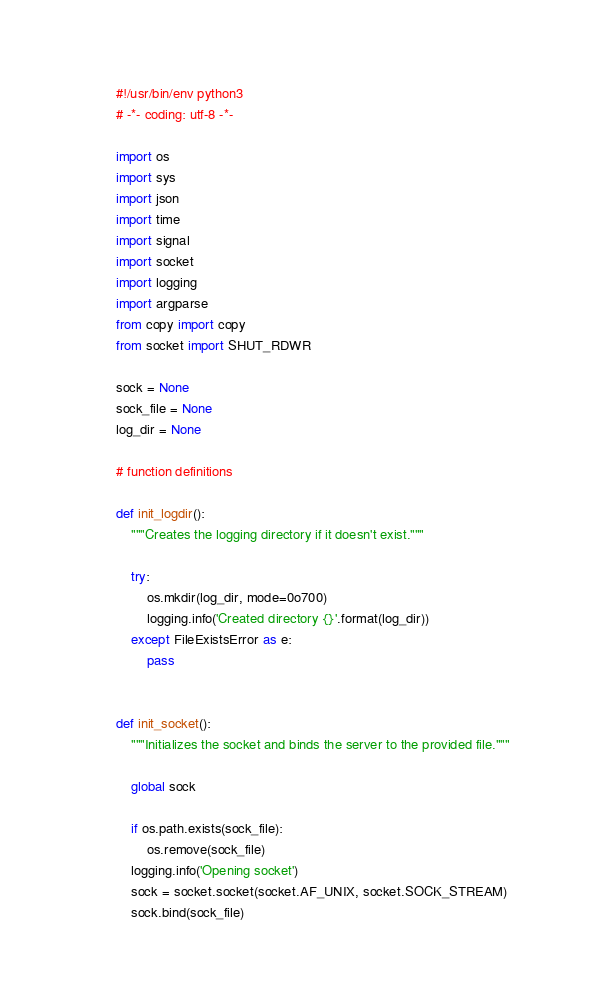<code> <loc_0><loc_0><loc_500><loc_500><_Python_>#!/usr/bin/env python3
# -*- coding: utf-8 -*-

import os
import sys
import json
import time
import signal
import socket
import logging
import argparse
from copy import copy
from socket import SHUT_RDWR

sock = None
sock_file = None
log_dir = None

# function definitions

def init_logdir():
    """Creates the logging directory if it doesn't exist."""

    try:
        os.mkdir(log_dir, mode=0o700)
        logging.info('Created directory {}'.format(log_dir))
    except FileExistsError as e:
        pass


def init_socket():
    """Initializes the socket and binds the server to the provided file."""

    global sock

    if os.path.exists(sock_file):
        os.remove(sock_file)
    logging.info('Opening socket')
    sock = socket.socket(socket.AF_UNIX, socket.SOCK_STREAM)
    sock.bind(sock_file)</code> 